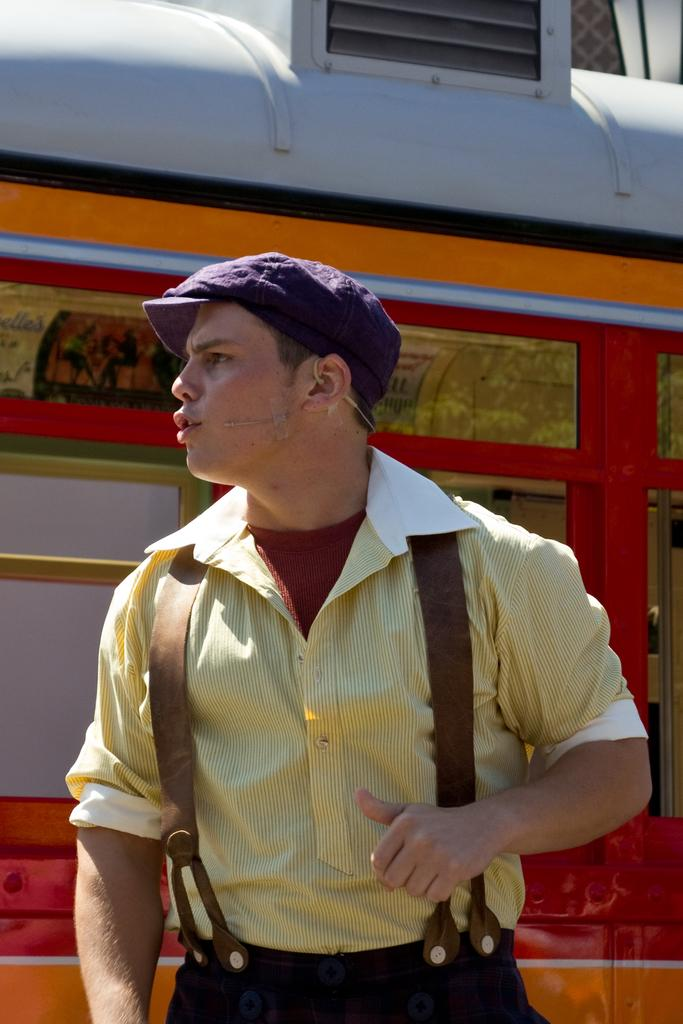Who is present in the image? There is a man in the image. What is the man wearing on his head? The man is wearing a cap. What can be seen behind the man? There is a vehicle behind the man. What object is present in the image that is typically used for amplifying sound? There is a microphone in the image. What type of pancake is the man flipping in the image? There is no pancake present in the image, and the man is not flipping anything. 